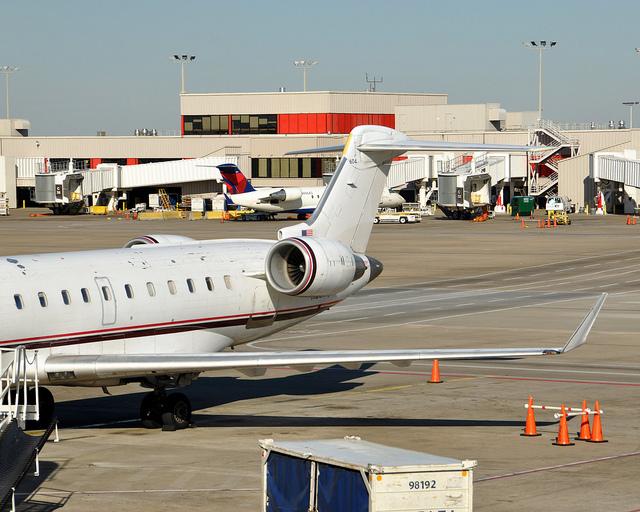How many cones are in the picture?
Keep it brief. 15. Where is this airport?
Concise answer only. Usa. Where is the shadow?
Short answer required. Under plane. 